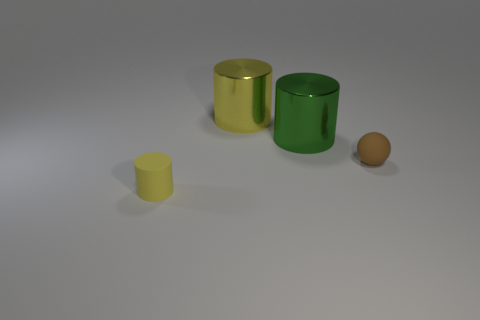What size is the yellow cylinder behind the matte object that is on the right side of the yellow cylinder right of the yellow rubber thing?
Ensure brevity in your answer.  Large. Are there any cylinders on the left side of the yellow cylinder that is behind the yellow rubber thing?
Provide a succinct answer. Yes. There is a small yellow object that is in front of the big cylinder that is left of the green object; how many cylinders are behind it?
Offer a very short reply. 2. What color is the cylinder that is both in front of the big yellow metallic cylinder and behind the matte cylinder?
Your response must be concise. Green. How many things are the same color as the rubber cylinder?
Ensure brevity in your answer.  1. How many cubes are either brown objects or tiny yellow things?
Give a very brief answer. 0. The other rubber object that is the same size as the yellow matte object is what color?
Provide a short and direct response. Brown. Are there any large metallic objects in front of the matte thing to the right of the small object that is to the left of the yellow metallic object?
Provide a short and direct response. No. The green object is what size?
Offer a very short reply. Large. How many objects are either brown rubber things or large gray cylinders?
Provide a succinct answer. 1. 